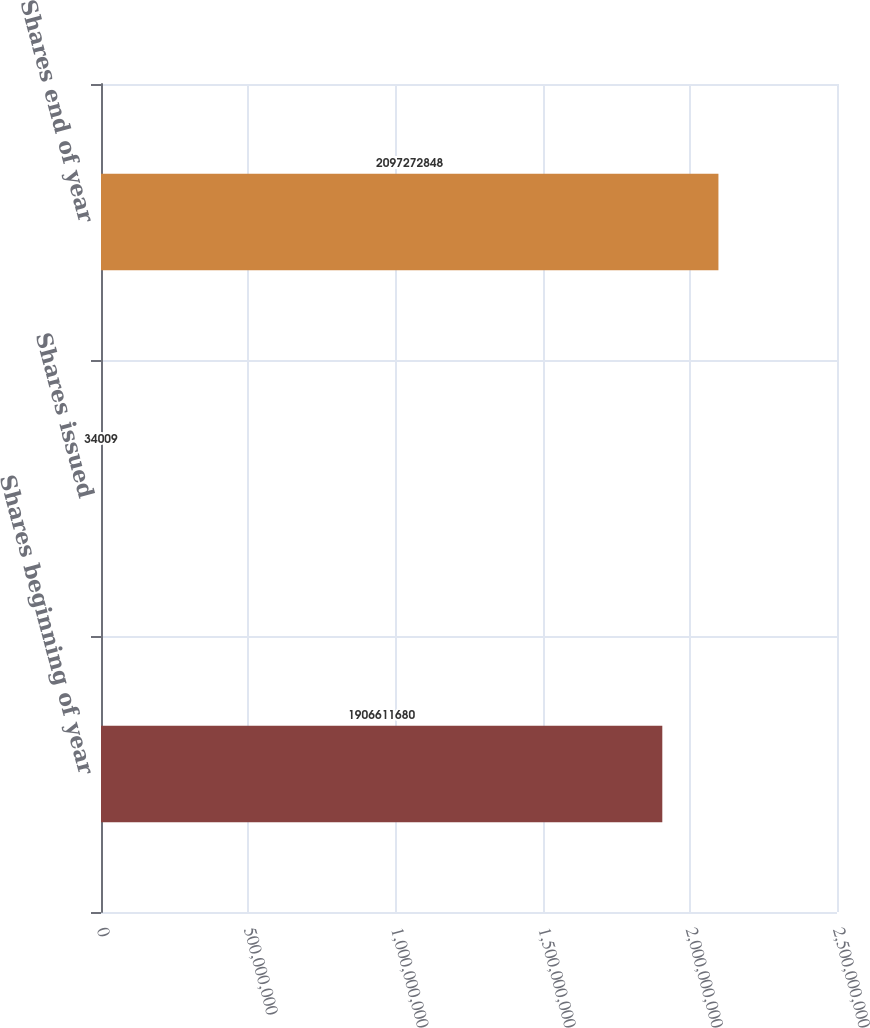Convert chart to OTSL. <chart><loc_0><loc_0><loc_500><loc_500><bar_chart><fcel>Shares beginning of year<fcel>Shares issued<fcel>Shares end of year<nl><fcel>1.90661e+09<fcel>34009<fcel>2.09727e+09<nl></chart> 